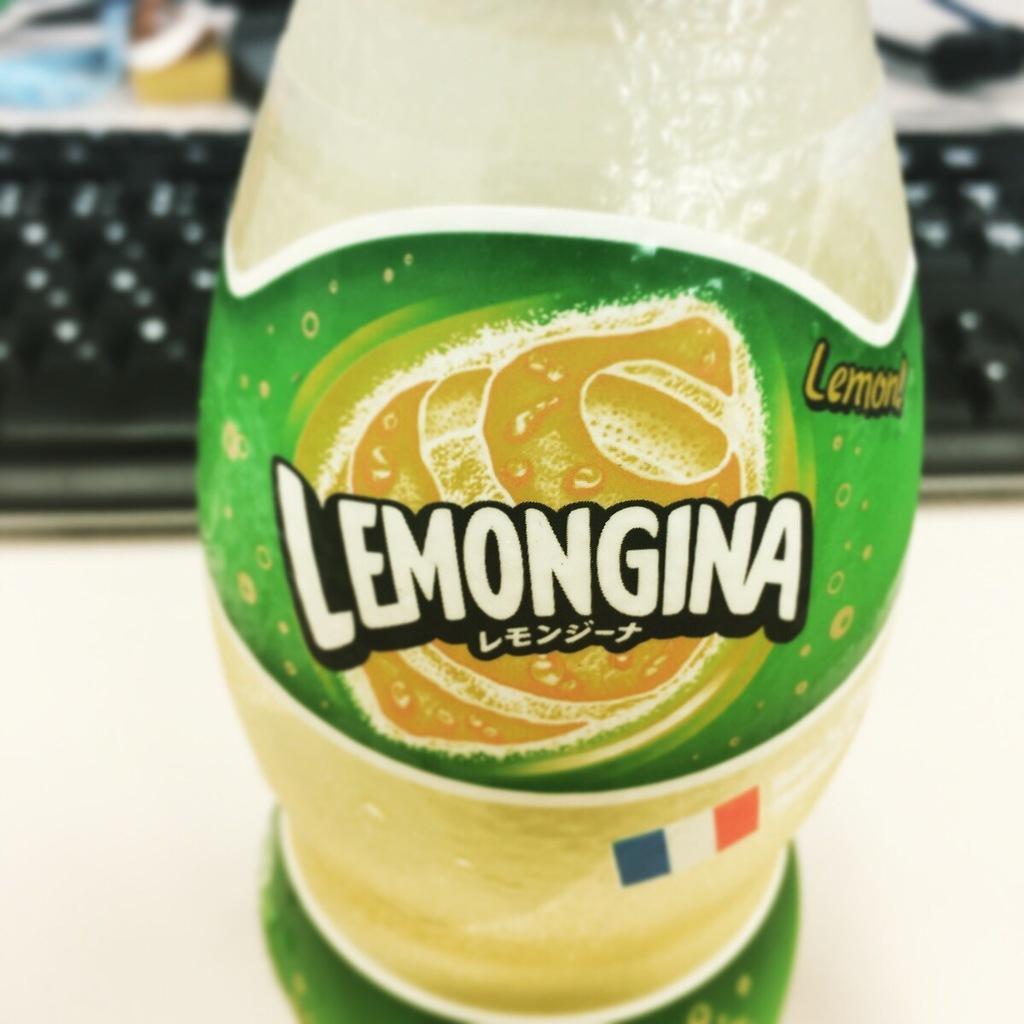How would you summarize this image in a sentence or two? In this image, we can see a drink where "Lemongina" label is placed on the drink and at the back of the drink we can see a key board. 